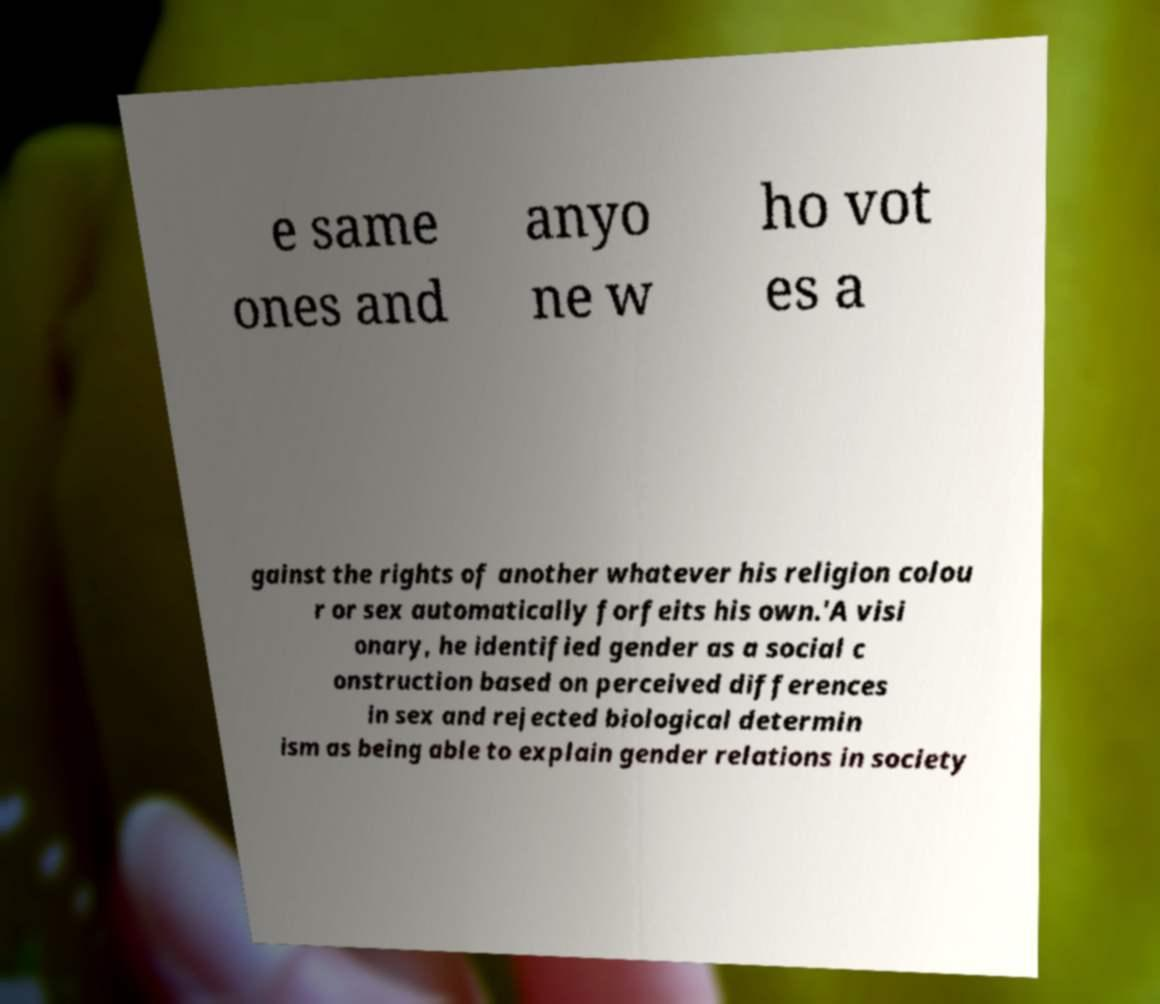There's text embedded in this image that I need extracted. Can you transcribe it verbatim? e same ones and anyo ne w ho vot es a gainst the rights of another whatever his religion colou r or sex automatically forfeits his own.'A visi onary, he identified gender as a social c onstruction based on perceived differences in sex and rejected biological determin ism as being able to explain gender relations in society 